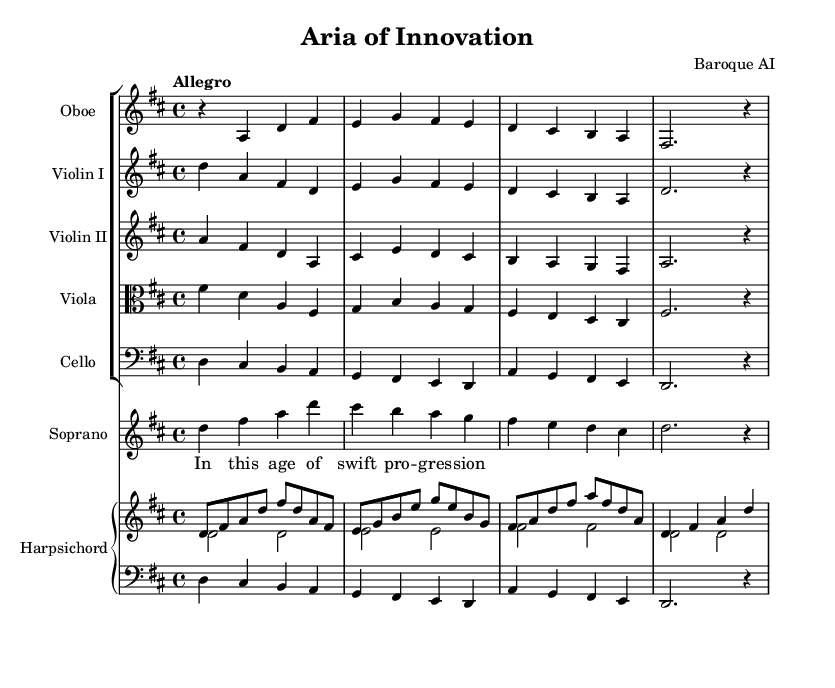What is the key signature of this music? The key signature shown in the sheet music is D major, which has two sharps (F# and C#). This can be identified at the beginning of the staff where the sharps are marked.
Answer: D major What is the time signature of this piece? The time signature displayed in the sheet music is 4/4, indicated at the beginning of the score. This means there are four beats per measure, and the quarter note gets one beat.
Answer: 4/4 What is the tempo marking for this composition? The tempo marking indicated in the sheet music is "Allegro," which implies a fast and lively pace. This can be found at the top of the score, under the initial instructions.
Answer: Allegro Which instruments are included in this ensemble? The ensemble includes Oboe, Violin I, Violin II, Viola, Cello, and Harpsichord. This can be seen from the instrument names listed at the start of each staff in the score.
Answer: Oboe, Violin I, Violin II, Viola, Cello, Harpsichord What is the first lyric sung by the soprano? The first lyric sung by the soprano voice is "In this age of swift pro -- gres -- sion," as indicated in the lyric mode section directly under the soprano staff. This identifies the opening line of the aria.
Answer: In this age of swift pro -- gres -- sion How many measures are in the soprano line? The soprano line contains a total of six measures, as counted from the beginning of the vocal part to the end of the provided excerpt. This can be determined by looking at the vertical bar lines that separate each measure.
Answer: 6 What musical period does this piece belong to? This piece belongs to the Baroque period, characterized by its ornate musical style, use of ornamentation, and the inclusion of forms such as opera. The overall characteristics of the music align with typical Baroque elements.
Answer: Baroque 